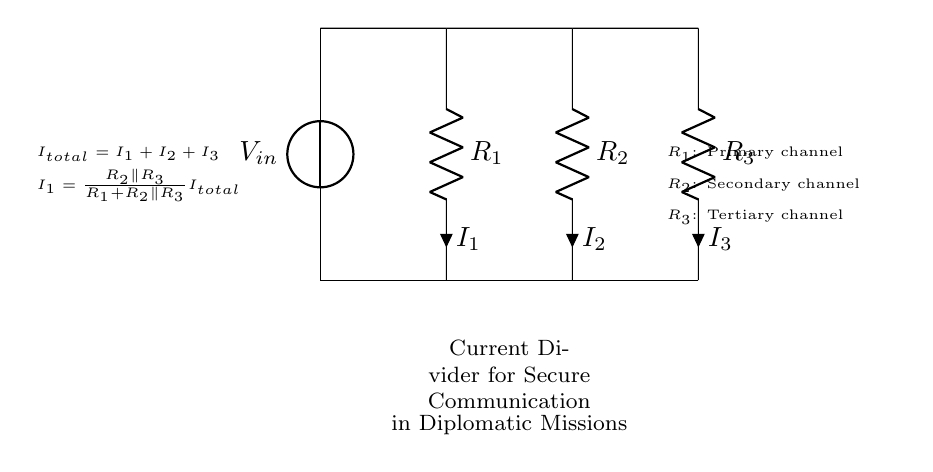what is the input voltage of this circuit? The input voltage is labeled as V_{in} in the circuit diagram, which is the voltage source that provides the total voltage to the circuit.
Answer: V_{in} how many resistors are in this current divider circuit? There are three resistors labeled R_{1}, R_{2}, and R_{3}, as seen in the circuit diagram.
Answer: 3 what is the total current flowing in the circuit? The total current, denoted as I_{total}, is the sum of the currents through all three resistors in the circuit.
Answer: I_{total} which resistor corresponds to the primary communication channel? R_{1} is identified as the primary channel according to the annotations in the circuit diagram, indicating its significance in secure communication.
Answer: R_{1} how does the current divide among the resistors? The current divides among the resistors based on their resistance values, where higher resistance results in lower current flow, as shown in the current divider principle depicted in the circuit.
Answer: Based on resistance values 